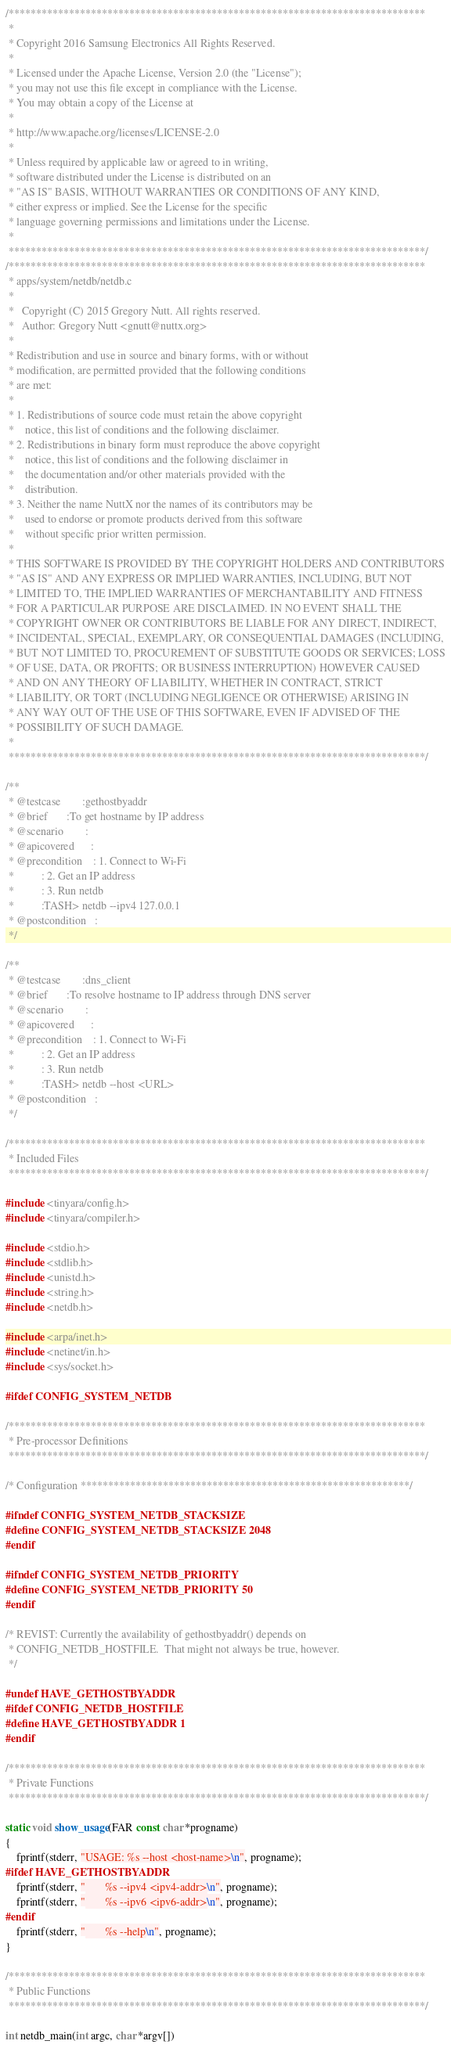<code> <loc_0><loc_0><loc_500><loc_500><_C_>/****************************************************************************
 *
 * Copyright 2016 Samsung Electronics All Rights Reserved.
 *
 * Licensed under the Apache License, Version 2.0 (the "License");
 * you may not use this file except in compliance with the License.
 * You may obtain a copy of the License at
 *
 * http://www.apache.org/licenses/LICENSE-2.0
 *
 * Unless required by applicable law or agreed to in writing,
 * software distributed under the License is distributed on an
 * "AS IS" BASIS, WITHOUT WARRANTIES OR CONDITIONS OF ANY KIND,
 * either express or implied. See the License for the specific
 * language governing permissions and limitations under the License.
 *
 ****************************************************************************/
/****************************************************************************
 * apps/system/netdb/netdb.c
 *
 *   Copyright (C) 2015 Gregory Nutt. All rights reserved.
 *   Author: Gregory Nutt <gnutt@nuttx.org>
 *
 * Redistribution and use in source and binary forms, with or without
 * modification, are permitted provided that the following conditions
 * are met:
 *
 * 1. Redistributions of source code must retain the above copyright
 *    notice, this list of conditions and the following disclaimer.
 * 2. Redistributions in binary form must reproduce the above copyright
 *    notice, this list of conditions and the following disclaimer in
 *    the documentation and/or other materials provided with the
 *    distribution.
 * 3. Neither the name NuttX nor the names of its contributors may be
 *    used to endorse or promote products derived from this software
 *    without specific prior written permission.
 *
 * THIS SOFTWARE IS PROVIDED BY THE COPYRIGHT HOLDERS AND CONTRIBUTORS
 * "AS IS" AND ANY EXPRESS OR IMPLIED WARRANTIES, INCLUDING, BUT NOT
 * LIMITED TO, THE IMPLIED WARRANTIES OF MERCHANTABILITY AND FITNESS
 * FOR A PARTICULAR PURPOSE ARE DISCLAIMED. IN NO EVENT SHALL THE
 * COPYRIGHT OWNER OR CONTRIBUTORS BE LIABLE FOR ANY DIRECT, INDIRECT,
 * INCIDENTAL, SPECIAL, EXEMPLARY, OR CONSEQUENTIAL DAMAGES (INCLUDING,
 * BUT NOT LIMITED TO, PROCUREMENT OF SUBSTITUTE GOODS OR SERVICES; LOSS
 * OF USE, DATA, OR PROFITS; OR BUSINESS INTERRUPTION) HOWEVER CAUSED
 * AND ON ANY THEORY OF LIABILITY, WHETHER IN CONTRACT, STRICT
 * LIABILITY, OR TORT (INCLUDING NEGLIGENCE OR OTHERWISE) ARISING IN
 * ANY WAY OUT OF THE USE OF THIS SOFTWARE, EVEN IF ADVISED OF THE
 * POSSIBILITY OF SUCH DAMAGE.
 *
 ****************************************************************************/

/**
 * @testcase		:gethostbyaddr
 * @brief		:To get hostname by IP address
 * @scenario		:
 * @apicovered		:
 * @precondition	: 1. Connect to Wi-Fi
 *			: 2. Get an IP address
 *			: 3. Run netdb
 *			:TASH> netdb --ipv4 127.0.0.1
 * @postcondition	:
 */

/**
 * @testcase		:dns_client
 * @brief		:To resolve hostname to IP address through DNS server
 * @scenario		:
 * @apicovered		:
 * @precondition	: 1. Connect to Wi-Fi
 *			: 2. Get an IP address
 *			: 3. Run netdb
 *			:TASH> netdb --host <URL>
 * @postcondition	:
 */

/****************************************************************************
 * Included Files
 ****************************************************************************/

#include <tinyara/config.h>
#include <tinyara/compiler.h>

#include <stdio.h>
#include <stdlib.h>
#include <unistd.h>
#include <string.h>
#include <netdb.h>

#include <arpa/inet.h>
#include <netinet/in.h>
#include <sys/socket.h>

#ifdef CONFIG_SYSTEM_NETDB

/****************************************************************************
 * Pre-processor Definitions
 ****************************************************************************/

/* Configuration ************************************************************/

#ifndef CONFIG_SYSTEM_NETDB_STACKSIZE
#define CONFIG_SYSTEM_NETDB_STACKSIZE 2048
#endif

#ifndef CONFIG_SYSTEM_NETDB_PRIORITY
#define CONFIG_SYSTEM_NETDB_PRIORITY 50
#endif

/* REVIST: Currently the availability of gethostbyaddr() depends on
 * CONFIG_NETDB_HOSTFILE.  That might not always be true, however.
 */

#undef HAVE_GETHOSTBYADDR
#ifdef CONFIG_NETDB_HOSTFILE
#define HAVE_GETHOSTBYADDR 1
#endif

/****************************************************************************
 * Private Functions
 ****************************************************************************/

static void show_usage(FAR const char *progname)
{
	fprintf(stderr, "USAGE: %s --host <host-name>\n", progname);
#ifdef HAVE_GETHOSTBYADDR
	fprintf(stderr, "       %s --ipv4 <ipv4-addr>\n", progname);
	fprintf(stderr, "       %s --ipv6 <ipv6-addr>\n", progname);
#endif
	fprintf(stderr, "       %s --help\n", progname);
}

/****************************************************************************
 * Public Functions
 ****************************************************************************/

int netdb_main(int argc, char *argv[])</code> 